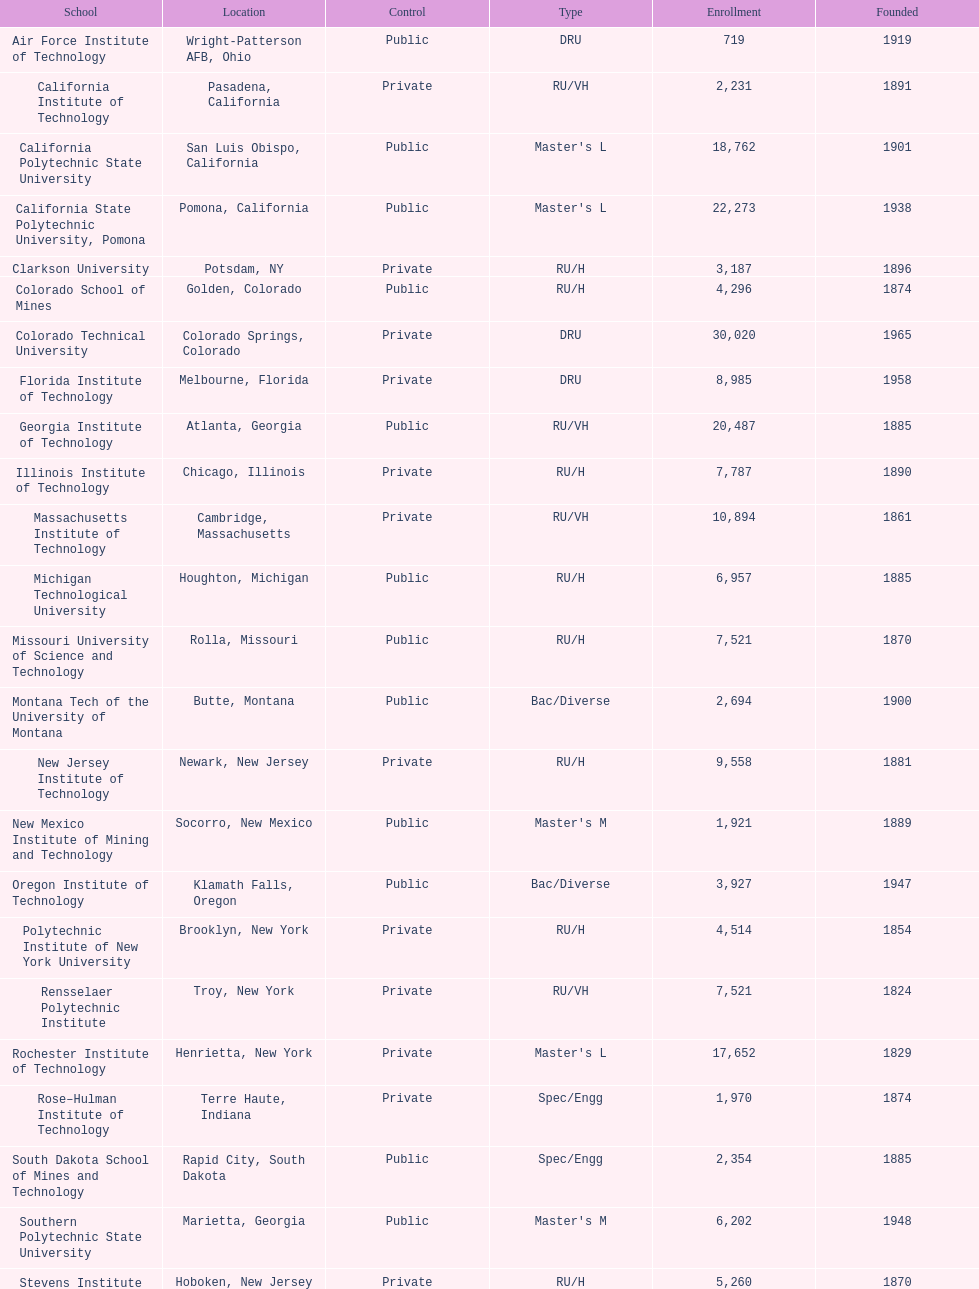Which of the educational institutions was established initially? Rensselaer Polytechnic Institute. 